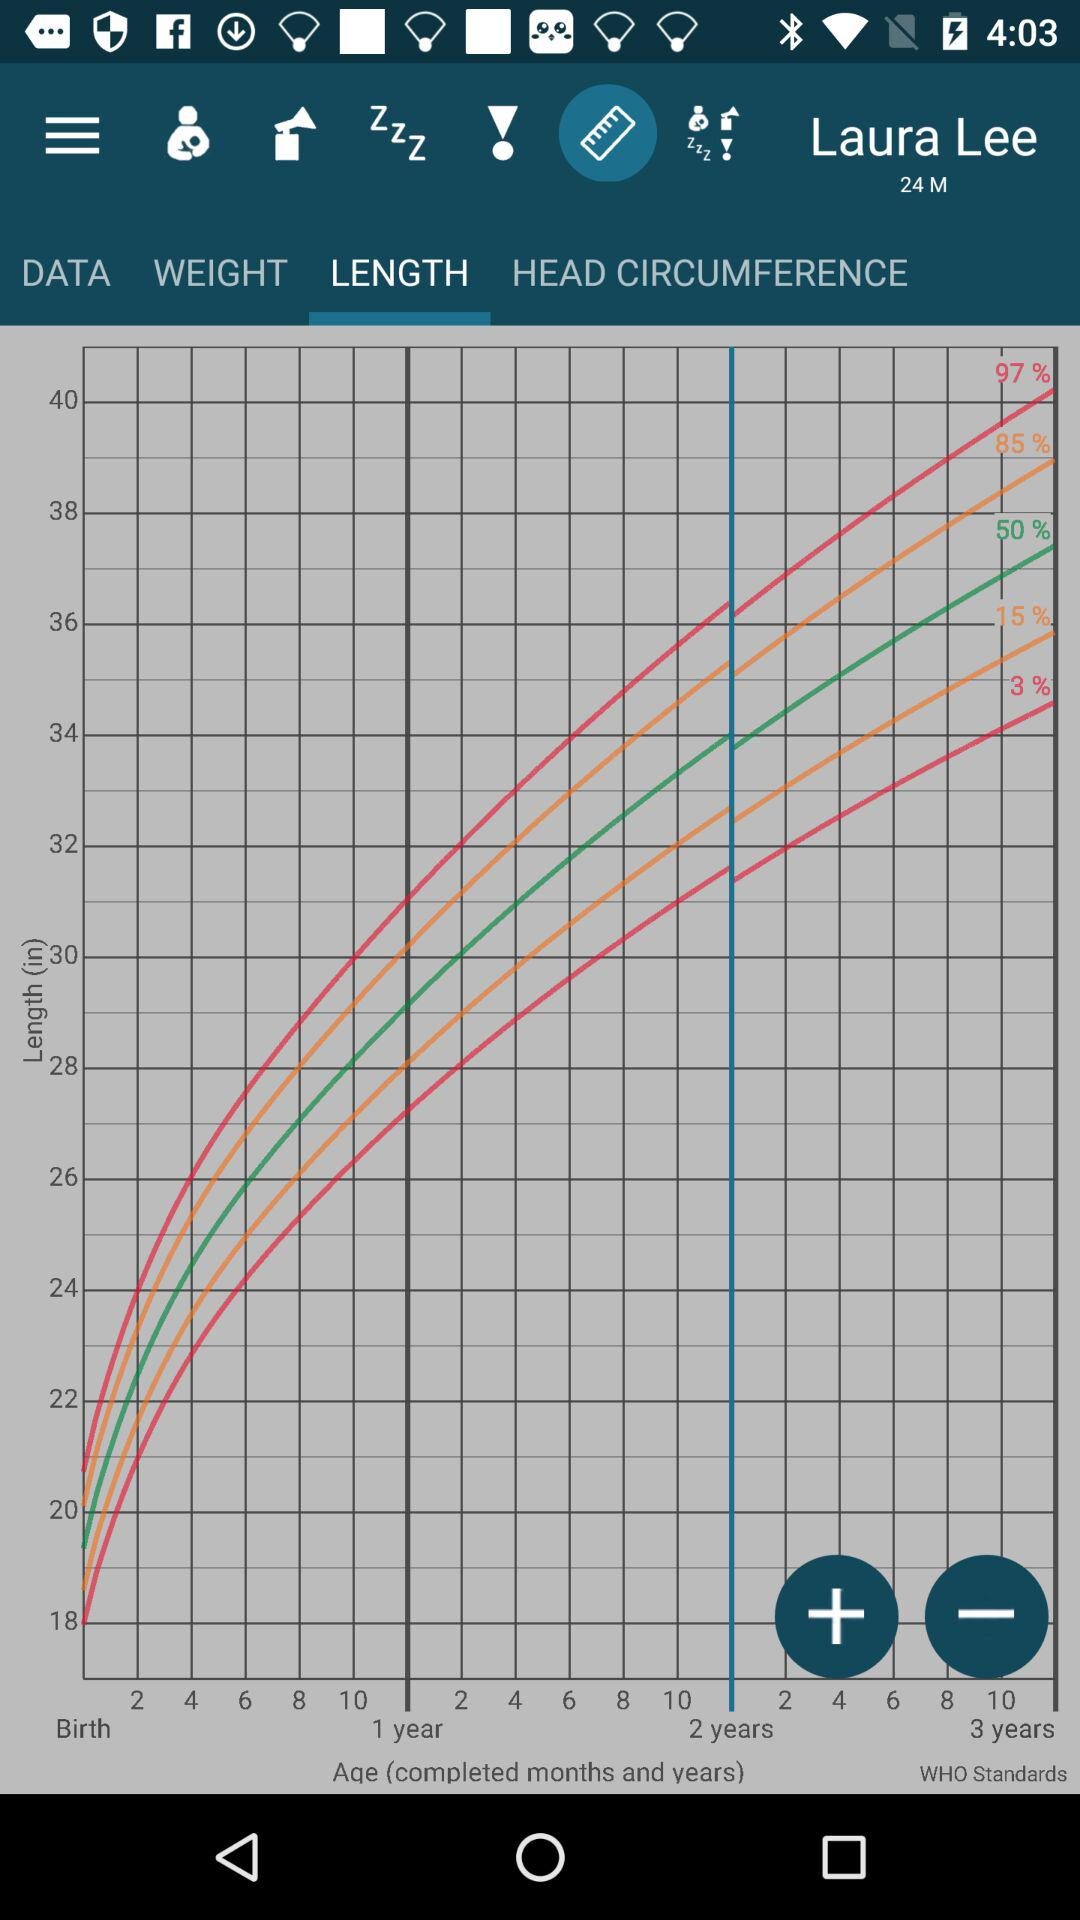What is the user name? The user name is Laura Lee. 